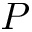<formula> <loc_0><loc_0><loc_500><loc_500>P</formula> 